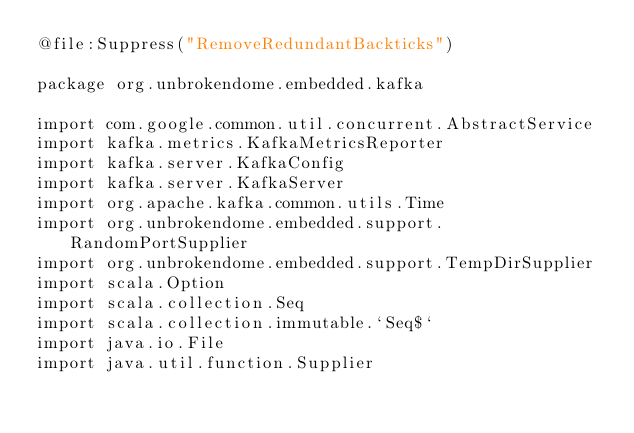Convert code to text. <code><loc_0><loc_0><loc_500><loc_500><_Kotlin_>@file:Suppress("RemoveRedundantBackticks")

package org.unbrokendome.embedded.kafka

import com.google.common.util.concurrent.AbstractService
import kafka.metrics.KafkaMetricsReporter
import kafka.server.KafkaConfig
import kafka.server.KafkaServer
import org.apache.kafka.common.utils.Time
import org.unbrokendome.embedded.support.RandomPortSupplier
import org.unbrokendome.embedded.support.TempDirSupplier
import scala.Option
import scala.collection.Seq
import scala.collection.immutable.`Seq$`
import java.io.File
import java.util.function.Supplier</code> 